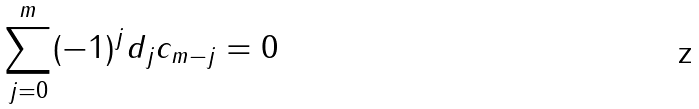<formula> <loc_0><loc_0><loc_500><loc_500>\sum _ { j = 0 } ^ { m } ( - 1 ) ^ { j } d _ { j } c _ { m - j } = 0</formula> 